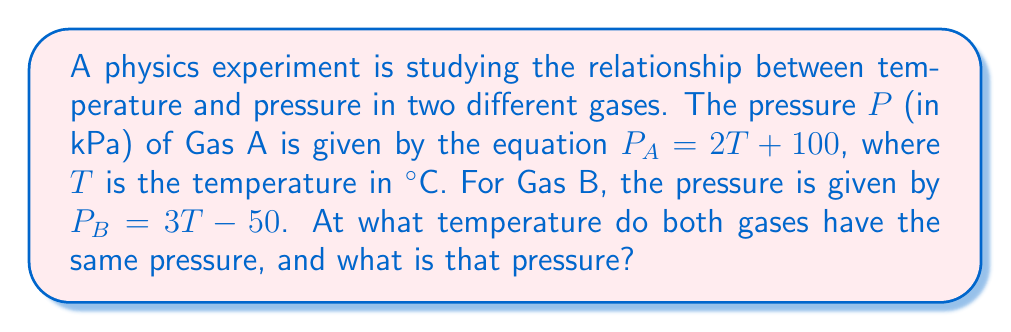Give your solution to this math problem. To solve this problem, we need to find the intersection point of the two linear functions representing the pressure-temperature relationships of Gas A and Gas B. Let's approach this step-by-step:

1) We have two equations:
   For Gas A: $P_A = 2T + 100$
   For Gas B: $P_B = 3T - 50$

2) At the intersection point, the pressures will be equal. So we can set up the equation:
   $P_A = P_B$
   $2T + 100 = 3T - 50$

3) Now we solve this equation for T:
   $2T + 100 = 3T - 50$
   $100 + 50 = 3T - 2T$
   $150 = T$

4) So the gases have the same pressure at 150°C.

5) To find the pressure at this temperature, we can substitute T = 150 into either of the original equations. Let's use Gas A's equation:
   $P = 2(150) + 100$
   $P = 300 + 100 = 400$

Therefore, the pressure at the intersection point is 400 kPa.

We can verify this by plugging 150°C into Gas B's equation:
$P_B = 3(150) - 50 = 450 - 50 = 400$ kPa

This confirms our result.
Answer: The gases have the same pressure at a temperature of 150°C, and the pressure at this point is 400 kPa. 